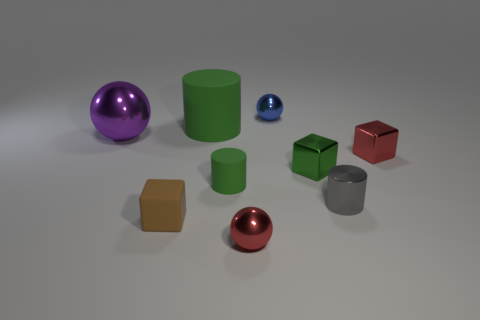There is a metallic sphere in front of the tiny green object on the left side of the red metallic thing in front of the small green rubber cylinder; how big is it?
Provide a succinct answer. Small. Is the size of the metal cylinder the same as the green cylinder behind the green cube?
Give a very brief answer. No. There is a green cylinder that is behind the large purple metal thing; is it the same size as the metallic sphere in front of the green metallic thing?
Your answer should be compact. No. What is the shape of the purple thing that is the same material as the gray cylinder?
Provide a succinct answer. Sphere. What number of other objects are there of the same shape as the blue shiny thing?
Your response must be concise. 2. What number of purple objects are either big metallic spheres or rubber cubes?
Keep it short and to the point. 1. Is the blue metallic object the same shape as the large purple metallic object?
Offer a terse response. Yes. There is a red object that is in front of the tiny brown matte cube; is there a tiny blue object in front of it?
Offer a very short reply. No. Are there an equal number of purple shiny things on the right side of the brown object and metal cylinders?
Offer a terse response. No. How many other things are there of the same size as the gray metallic object?
Offer a very short reply. 6. 